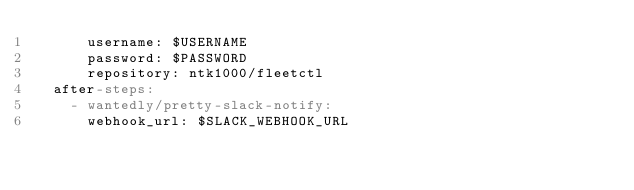<code> <loc_0><loc_0><loc_500><loc_500><_YAML_>      username: $USERNAME
      password: $PASSWORD
      repository: ntk1000/fleetctl
  after-steps:
    - wantedly/pretty-slack-notify:
      webhook_url: $SLACK_WEBHOOK_URL
</code> 